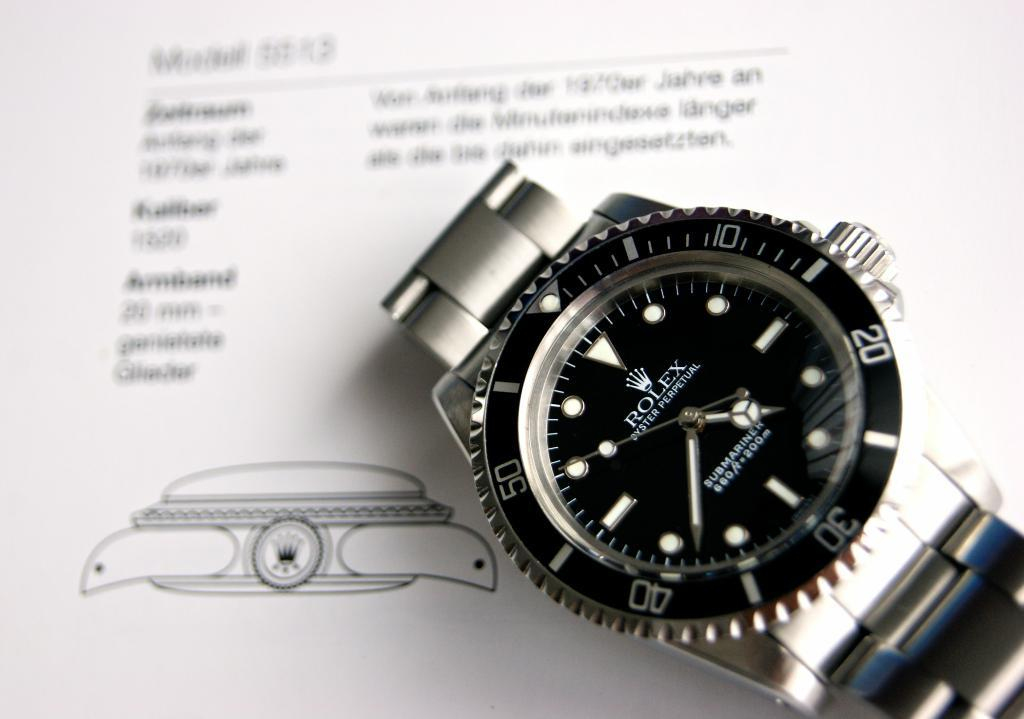<image>
Describe the image concisely. A watch against a paper backdrop which bears the name Rolex. 